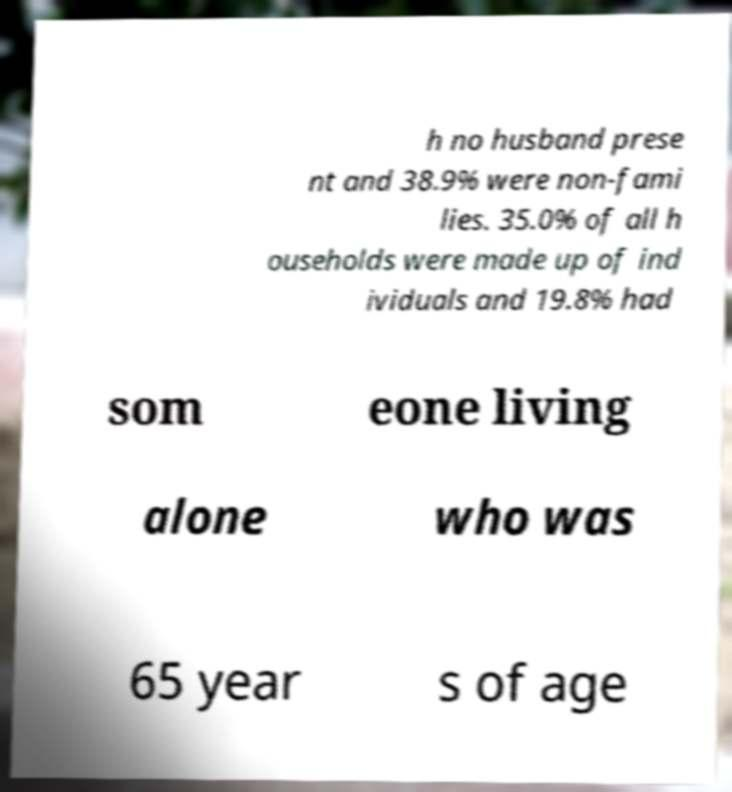Can you accurately transcribe the text from the provided image for me? h no husband prese nt and 38.9% were non-fami lies. 35.0% of all h ouseholds were made up of ind ividuals and 19.8% had som eone living alone who was 65 year s of age 